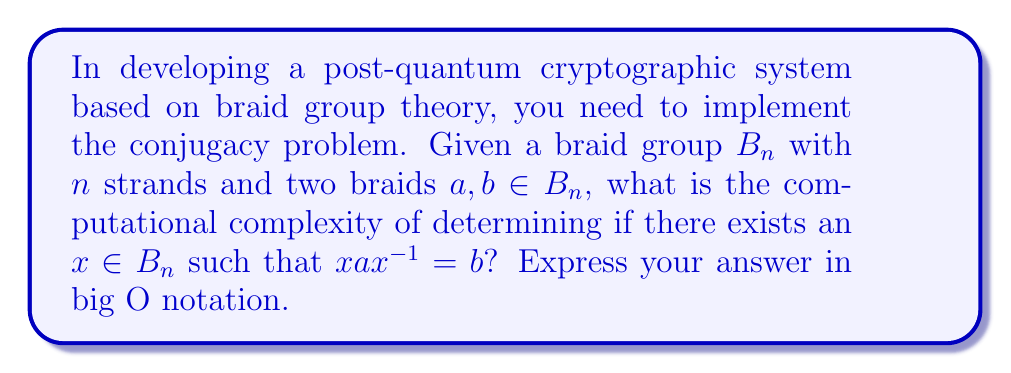Solve this math problem. To analyze the computational complexity of the conjugacy problem in braid groups, we need to consider the following steps:

1. The braid group $B_n$ has $n$ strands, and the length of each braid (number of crossings) is typically denoted as $l$.

2. The naive approach to solving the conjugacy problem would be to try all possible braids $x$ and check if $xax^{-1} = b$. However, this is impractical as the number of possible braids grows exponentially with $n$ and $l$.

3. The best known classical algorithm for solving the conjugacy problem in braid groups is the length-based attack, which has a time complexity of:

   $$O(exp(c\sqrt{n\log{n}}))$$

   where $c$ is a constant.

4. This complexity is sub-exponential in $n$, which makes it more efficient than brute-force methods but still computationally challenging for large $n$.

5. It's important to note that this complexity assumes that the length of the braids $a$ and $b$ is polynomial in $n$. If the length is exponential in $n$, the problem becomes even harder.

6. The difficulty of this problem is what makes it attractive for post-quantum cryptography. Quantum computers are not known to have a significant advantage in solving this problem, unlike integer factorization or discrete logarithms used in current cryptosystems.

7. However, when implementing this in a cryptographic system, you need to carefully choose the parameters $n$ and $l$ to ensure sufficient security while maintaining practical efficiency.
Answer: $O(exp(c\sqrt{n\log{n}}))$ 